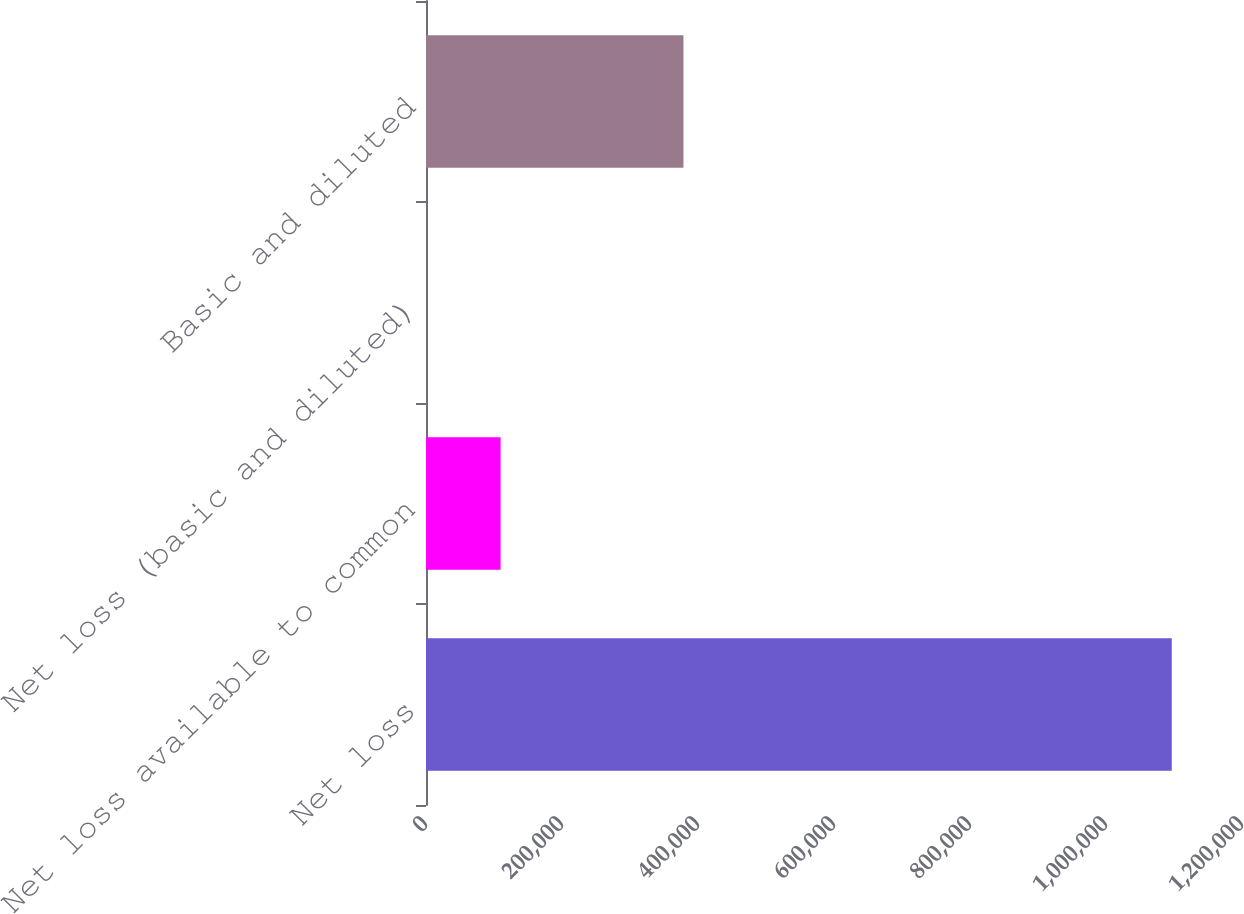Convert chart. <chart><loc_0><loc_0><loc_500><loc_500><bar_chart><fcel>Net loss<fcel>Net loss available to common<fcel>Net loss (basic and diluted)<fcel>Basic and diluted<nl><fcel>1.09673e+06<fcel>109676<fcel>2.9<fcel>378585<nl></chart> 